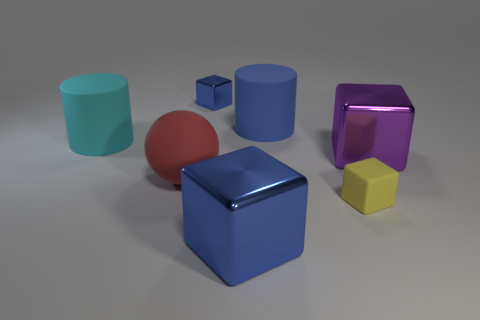What textures are present among the objects in the image? The collection of objects in the image displays a variety of textures. The large blue and small blue cubes appear glossy, reflecting light and giving them a shiny appearance. The pink cube has a reflective, almost glass-like texture. The red sphere and the teal cylinder seem to have a matte finish, diffusing light instead of reflecting it. The large purple cube has a more complex texture, resembling iridescence or a metallic finish. 